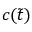Convert formula to latex. <formula><loc_0><loc_0><loc_500><loc_500>c ( \tilde { t } )</formula> 